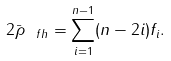Convert formula to latex. <formula><loc_0><loc_0><loc_500><loc_500>2 \bar { \rho } _ { \ f h } = \sum _ { i = 1 } ^ { n - 1 } ( n - 2 i ) f _ { i } .</formula> 